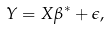Convert formula to latex. <formula><loc_0><loc_0><loc_500><loc_500>Y = X \beta ^ { * } + \epsilon ,</formula> 